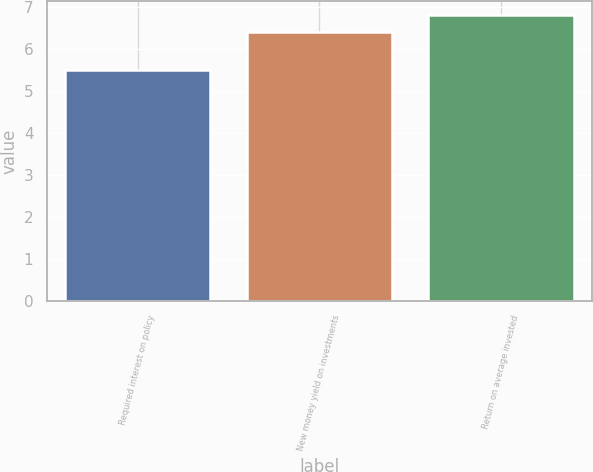Convert chart to OTSL. <chart><loc_0><loc_0><loc_500><loc_500><bar_chart><fcel>Required interest on policy<fcel>New money yield on investments<fcel>Return on average invested<nl><fcel>5.5<fcel>6.4<fcel>6.79<nl></chart> 